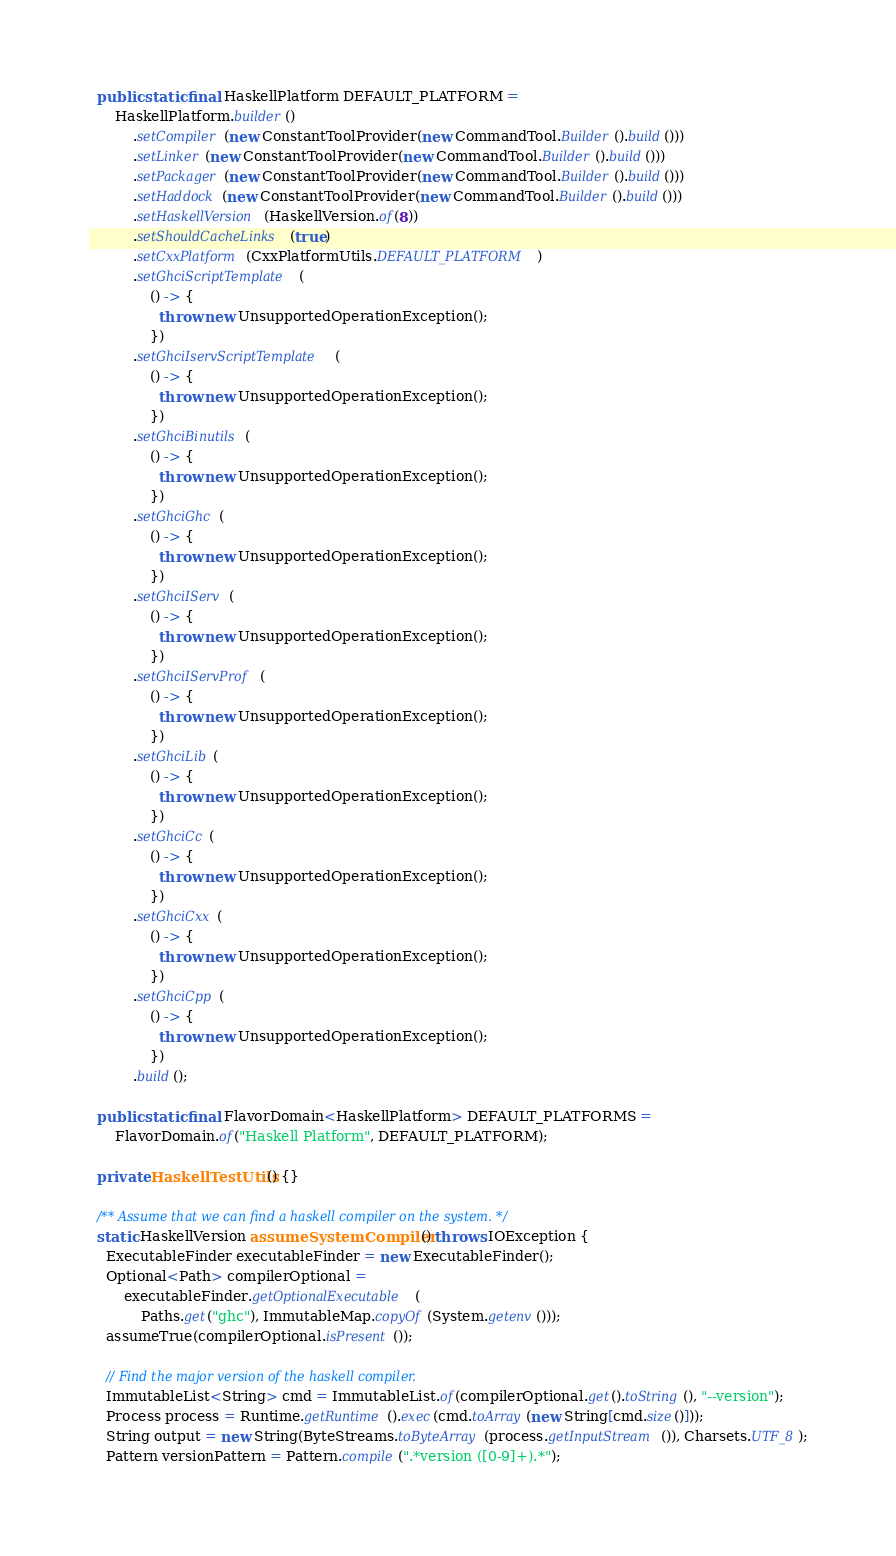Convert code to text. <code><loc_0><loc_0><loc_500><loc_500><_Java_>  public static final HaskellPlatform DEFAULT_PLATFORM =
      HaskellPlatform.builder()
          .setCompiler(new ConstantToolProvider(new CommandTool.Builder().build()))
          .setLinker(new ConstantToolProvider(new CommandTool.Builder().build()))
          .setPackager(new ConstantToolProvider(new CommandTool.Builder().build()))
          .setHaddock(new ConstantToolProvider(new CommandTool.Builder().build()))
          .setHaskellVersion(HaskellVersion.of(8))
          .setShouldCacheLinks(true)
          .setCxxPlatform(CxxPlatformUtils.DEFAULT_PLATFORM)
          .setGhciScriptTemplate(
              () -> {
                throw new UnsupportedOperationException();
              })
          .setGhciIservScriptTemplate(
              () -> {
                throw new UnsupportedOperationException();
              })
          .setGhciBinutils(
              () -> {
                throw new UnsupportedOperationException();
              })
          .setGhciGhc(
              () -> {
                throw new UnsupportedOperationException();
              })
          .setGhciIServ(
              () -> {
                throw new UnsupportedOperationException();
              })
          .setGhciIServProf(
              () -> {
                throw new UnsupportedOperationException();
              })
          .setGhciLib(
              () -> {
                throw new UnsupportedOperationException();
              })
          .setGhciCc(
              () -> {
                throw new UnsupportedOperationException();
              })
          .setGhciCxx(
              () -> {
                throw new UnsupportedOperationException();
              })
          .setGhciCpp(
              () -> {
                throw new UnsupportedOperationException();
              })
          .build();

  public static final FlavorDomain<HaskellPlatform> DEFAULT_PLATFORMS =
      FlavorDomain.of("Haskell Platform", DEFAULT_PLATFORM);

  private HaskellTestUtils() {}

  /** Assume that we can find a haskell compiler on the system. */
  static HaskellVersion assumeSystemCompiler() throws IOException {
    ExecutableFinder executableFinder = new ExecutableFinder();
    Optional<Path> compilerOptional =
        executableFinder.getOptionalExecutable(
            Paths.get("ghc"), ImmutableMap.copyOf(System.getenv()));
    assumeTrue(compilerOptional.isPresent());

    // Find the major version of the haskell compiler.
    ImmutableList<String> cmd = ImmutableList.of(compilerOptional.get().toString(), "--version");
    Process process = Runtime.getRuntime().exec(cmd.toArray(new String[cmd.size()]));
    String output = new String(ByteStreams.toByteArray(process.getInputStream()), Charsets.UTF_8);
    Pattern versionPattern = Pattern.compile(".*version ([0-9]+).*");</code> 